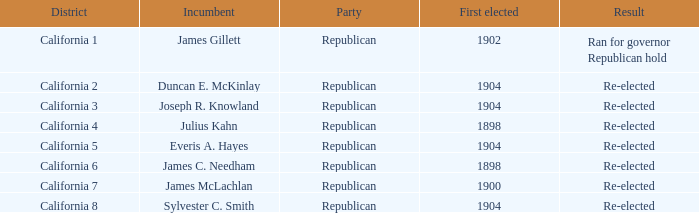Which area has a first elected representative from 1904 and a current incumbent named duncan e. mckinlay? California 2. Parse the table in full. {'header': ['District', 'Incumbent', 'Party', 'First elected', 'Result'], 'rows': [['California 1', 'James Gillett', 'Republican', '1902', 'Ran for governor Republican hold'], ['California 2', 'Duncan E. McKinlay', 'Republican', '1904', 'Re-elected'], ['California 3', 'Joseph R. Knowland', 'Republican', '1904', 'Re-elected'], ['California 4', 'Julius Kahn', 'Republican', '1898', 'Re-elected'], ['California 5', 'Everis A. Hayes', 'Republican', '1904', 'Re-elected'], ['California 6', 'James C. Needham', 'Republican', '1898', 'Re-elected'], ['California 7', 'James McLachlan', 'Republican', '1900', 'Re-elected'], ['California 8', 'Sylvester C. Smith', 'Republican', '1904', 'Re-elected']]} 